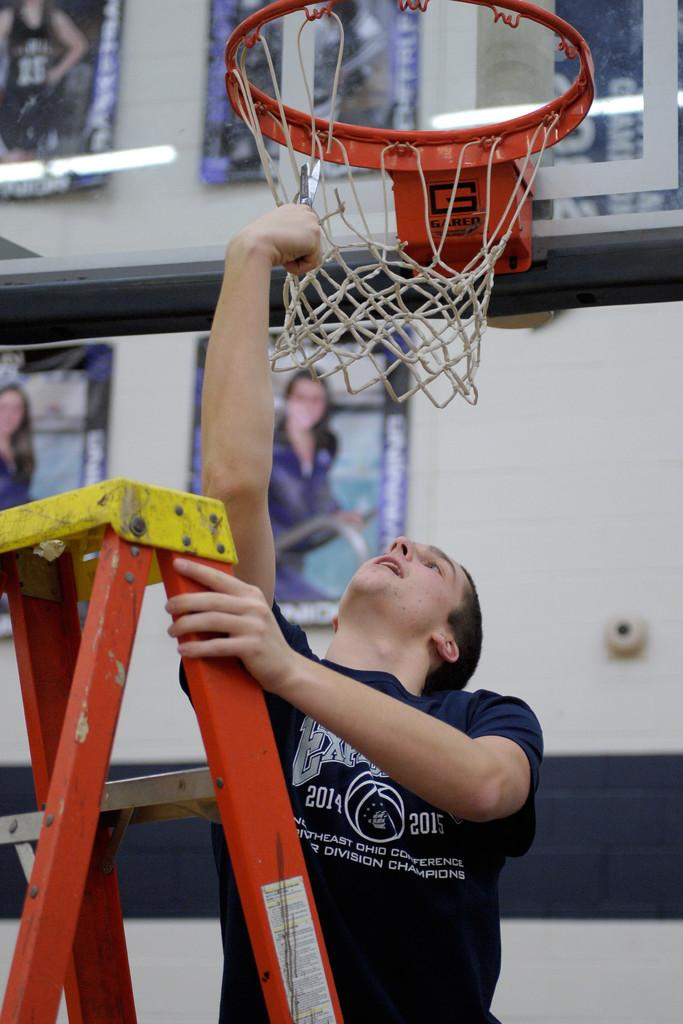Provide a one-sentence caption for the provided image. a guy fixing a basketball net that has the letter G on the neck of it. 